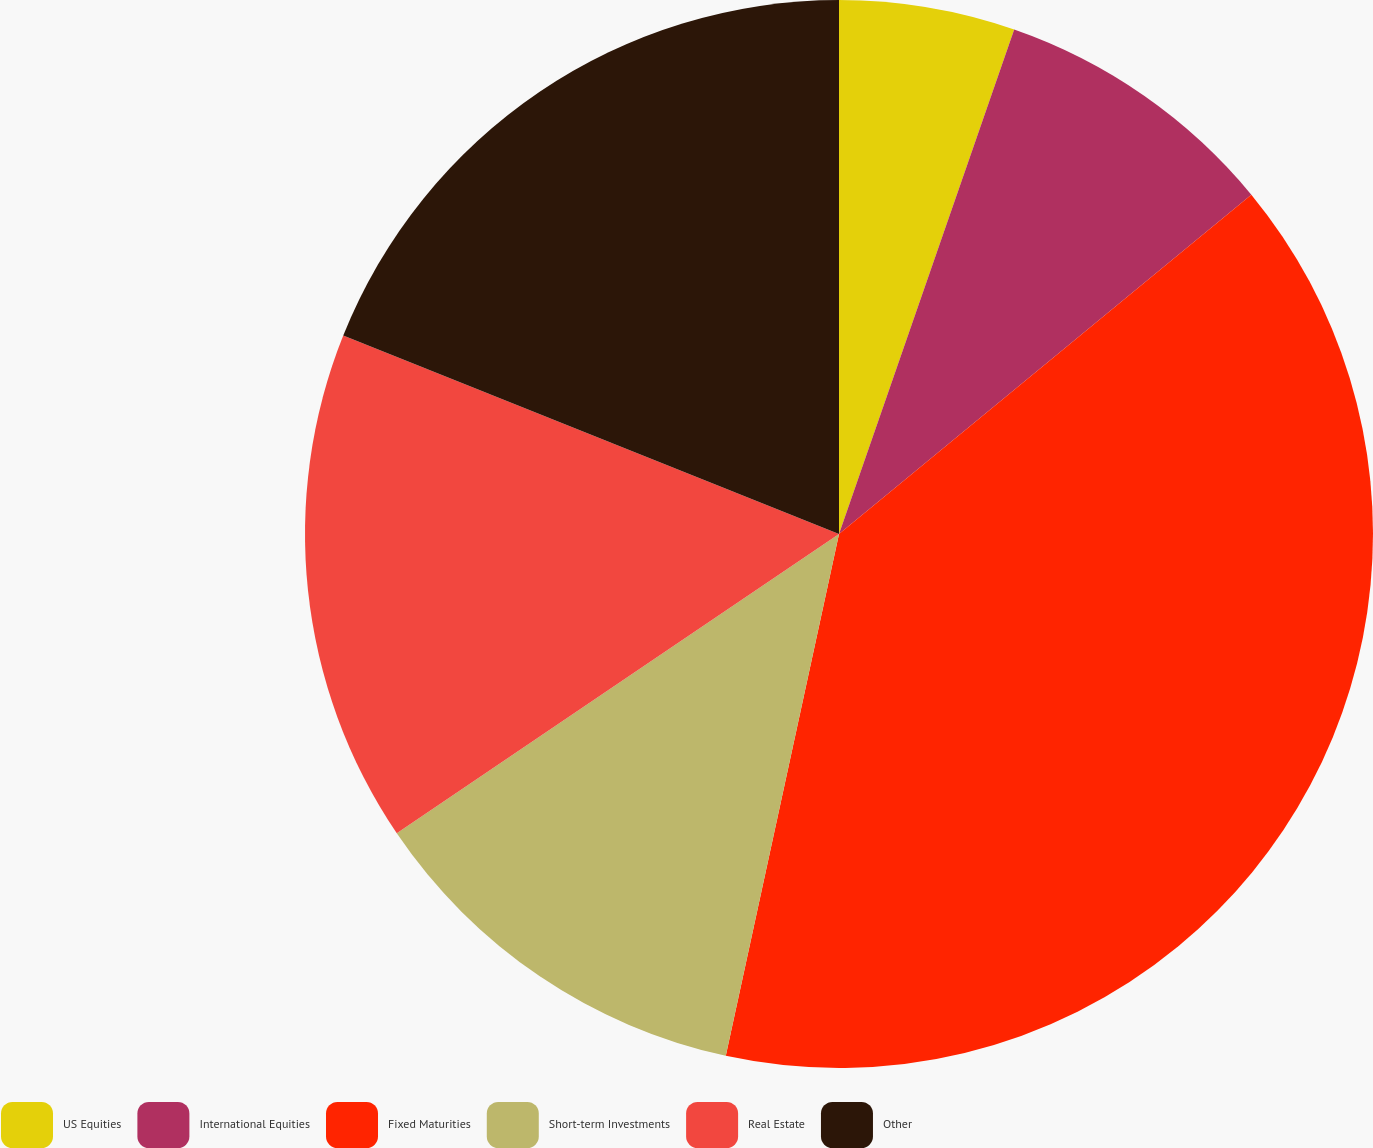Convert chart to OTSL. <chart><loc_0><loc_0><loc_500><loc_500><pie_chart><fcel>US Equities<fcel>International Equities<fcel>Fixed Maturities<fcel>Short-term Investments<fcel>Real Estate<fcel>Other<nl><fcel>5.32%<fcel>8.72%<fcel>39.36%<fcel>12.13%<fcel>15.53%<fcel>18.94%<nl></chart> 